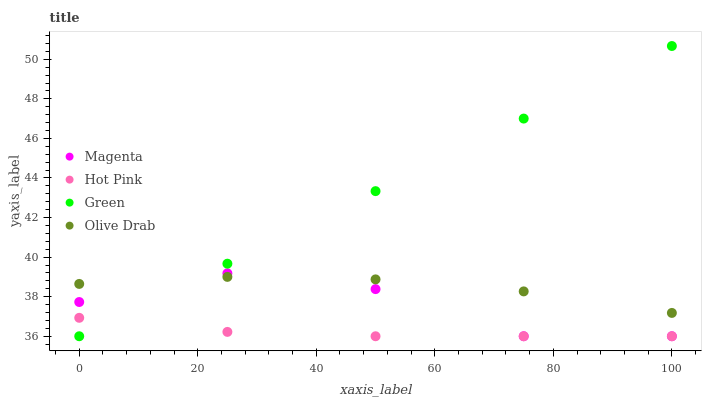Does Hot Pink have the minimum area under the curve?
Answer yes or no. Yes. Does Green have the maximum area under the curve?
Answer yes or no. Yes. Does Green have the minimum area under the curve?
Answer yes or no. No. Does Hot Pink have the maximum area under the curve?
Answer yes or no. No. Is Green the smoothest?
Answer yes or no. Yes. Is Magenta the roughest?
Answer yes or no. Yes. Is Hot Pink the smoothest?
Answer yes or no. No. Is Hot Pink the roughest?
Answer yes or no. No. Does Magenta have the lowest value?
Answer yes or no. Yes. Does Olive Drab have the lowest value?
Answer yes or no. No. Does Green have the highest value?
Answer yes or no. Yes. Does Hot Pink have the highest value?
Answer yes or no. No. Is Hot Pink less than Olive Drab?
Answer yes or no. Yes. Is Olive Drab greater than Hot Pink?
Answer yes or no. Yes. Does Magenta intersect Green?
Answer yes or no. Yes. Is Magenta less than Green?
Answer yes or no. No. Is Magenta greater than Green?
Answer yes or no. No. Does Hot Pink intersect Olive Drab?
Answer yes or no. No. 